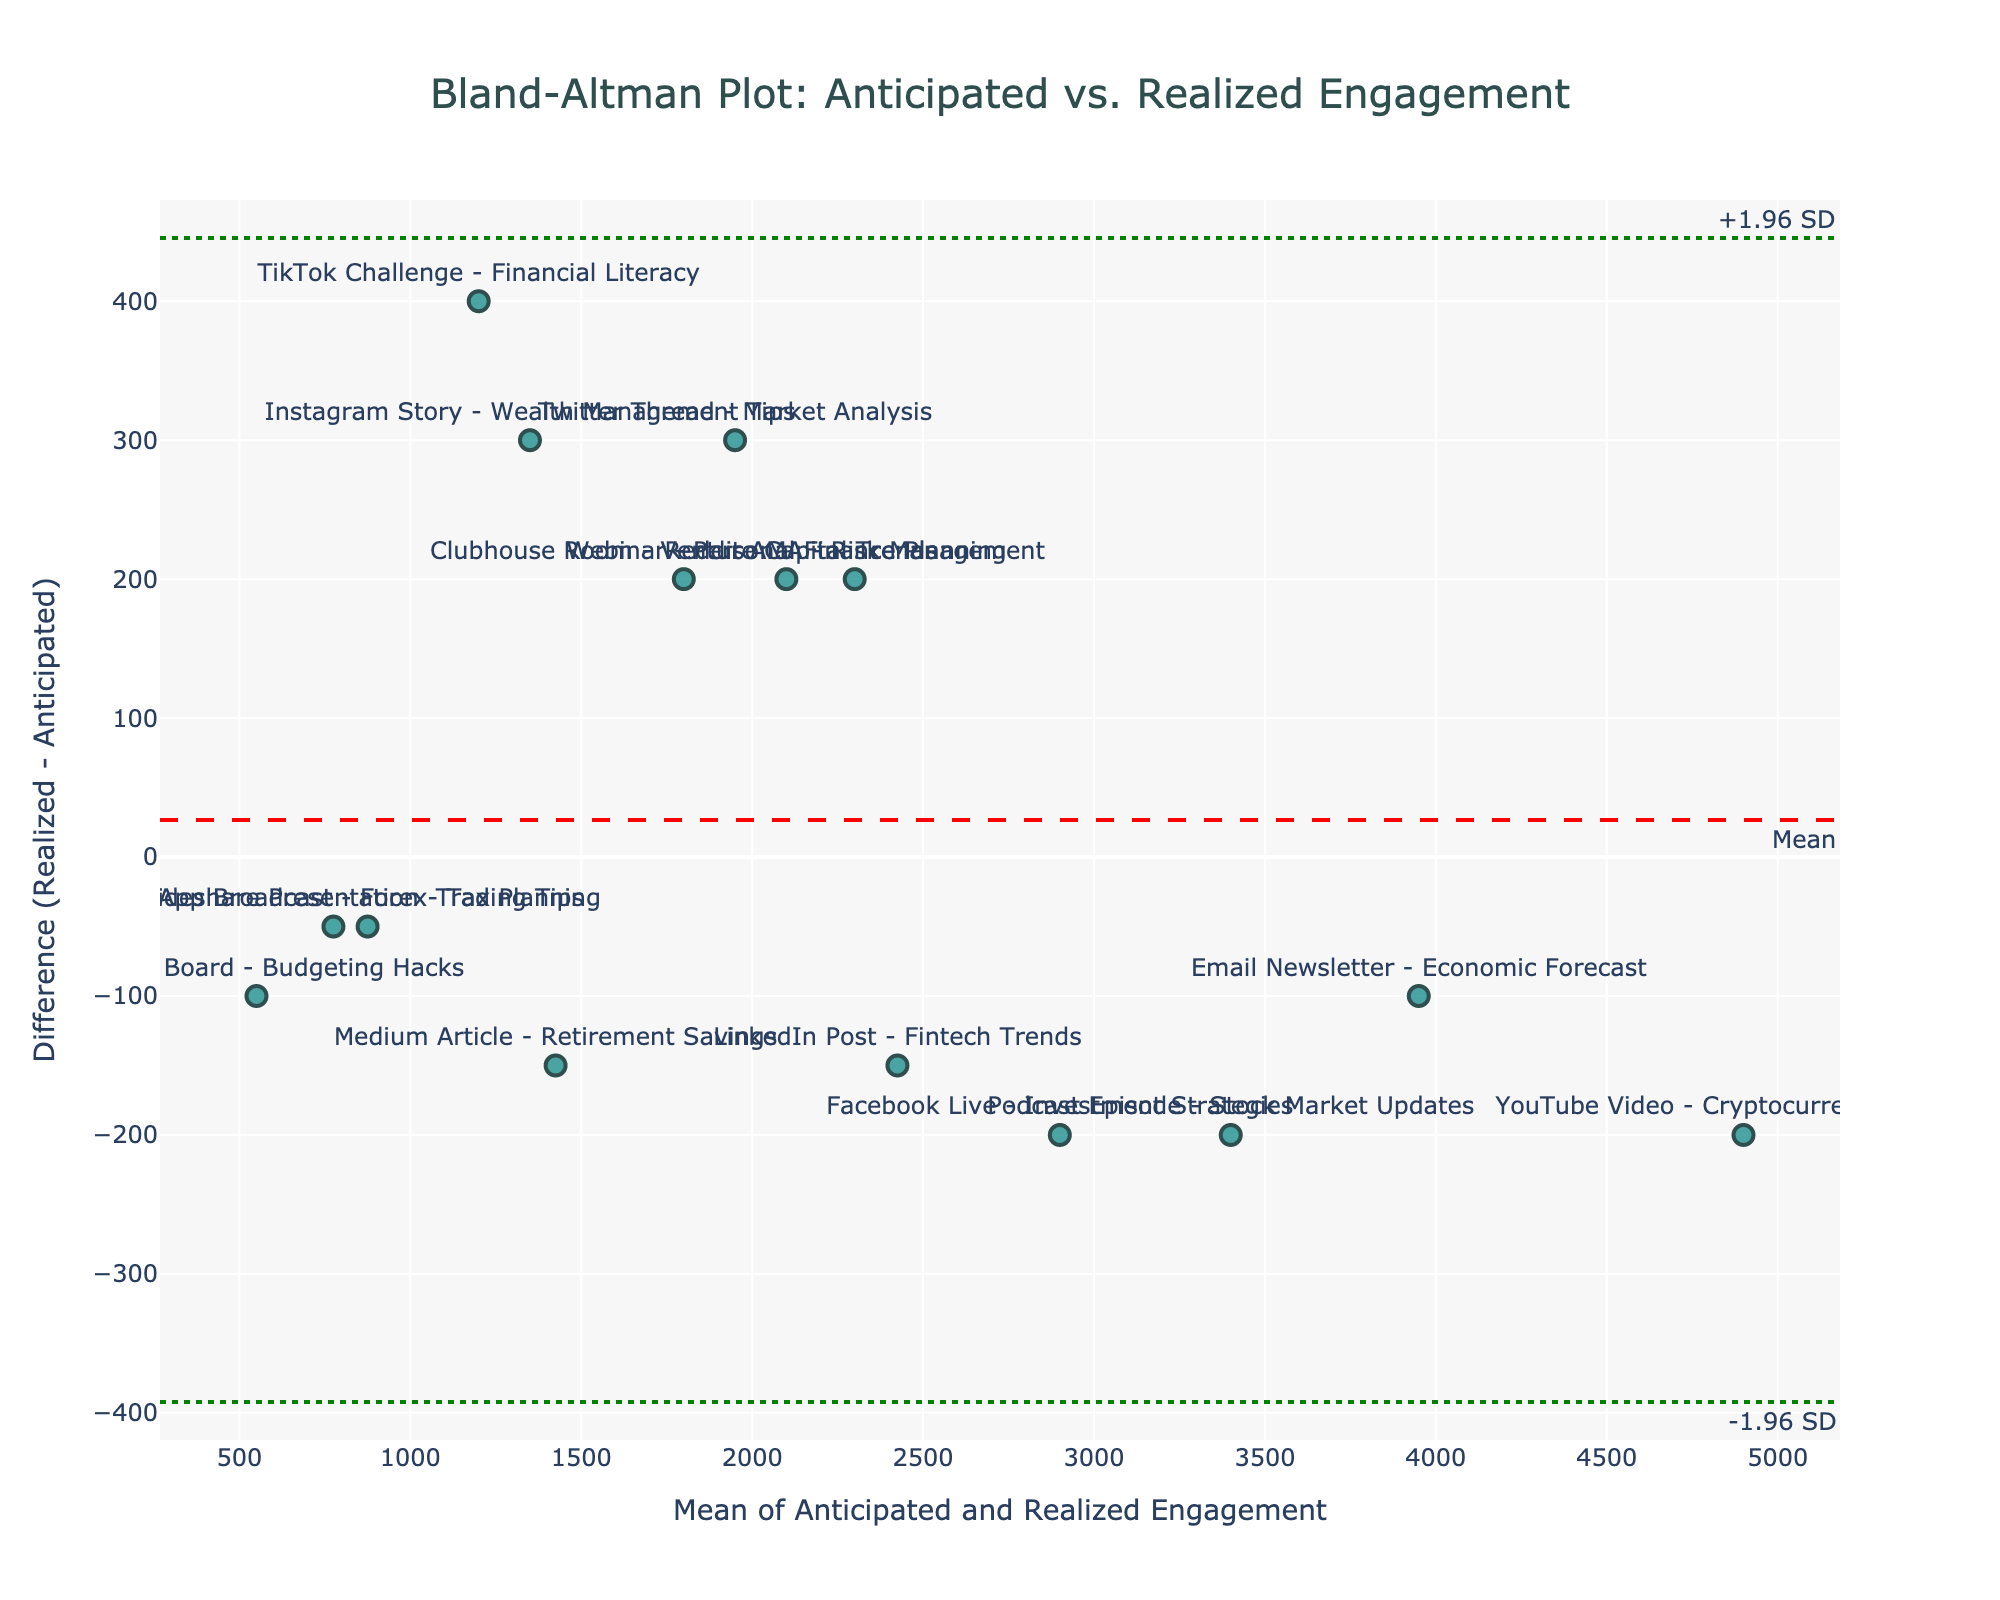What is the title of the figure? The title is displayed at the top of the figure and in this case, it is centered.
Answer: Bland-Altman Plot: Anticipated vs. Realized Engagement How many data points are plotted in the figure? By visually counting the markers or the text labels of each method, we can determine the total number of data points.
Answer: 15 Which method has the highest anticipated engagement? By looking at the data and visually identifying the highest x-axis value which is the mean of anticipated and realized engagement, the method 'YouTube Video - Cryptocurrency Insights' has the highest anticipated engagement since it appears furthest to the right.
Answer: YouTube Video - Cryptocurrency Insights What is the purpose of the red dashed line in the plot? The red dashed line represents the mean difference between the realized and anticipated engagement metrics. This line helps to visualize the average discrepancy.
Answer: Mean difference What do the green dotted lines represent? The green dotted lines represent the limits of agreement, which are calculated as mean difference ± 1.96 times the standard deviation of the differences. These lines indicate the range within which most differences are expected to lie.
Answer: Limits of agreement Which method shows the largest positive difference between realized and anticipated engagement? By looking at the y-axis values, the method 'Twitter Thread - Market Analysis' has a high position, indicating the largest positive difference between realized and anticipated engagement.
Answer: Twitter Thread - Market Analysis What is the approximate value of the mean difference? The mean difference can be found by looking at the red dashed line's y-axis value, which indicates how much higher or lower the realized engagements are on average compared to anticipated engagements.
Answer: Approximately -133 How does the Webinar - Personal Finance Planning method compare in terms of the engagement difference? It is located above the mean difference line (red dash) and within the limits of agreement (green dots), indicating a positive but not unusual difference from anticipated engagement.
Answer: Positive difference within limits Are any methods significantly outside the limits of agreement? By assessing which points fall outside the green dotted lines, 'TikTok Challenge - Financial Literacy' and 'Instagram Story - Wealth Management Tips' both stand out as being significantly outside the upper limit.
Answer: TikTok Challenge - Financial Literacy, Instagram Story - Wealth Management Tips 